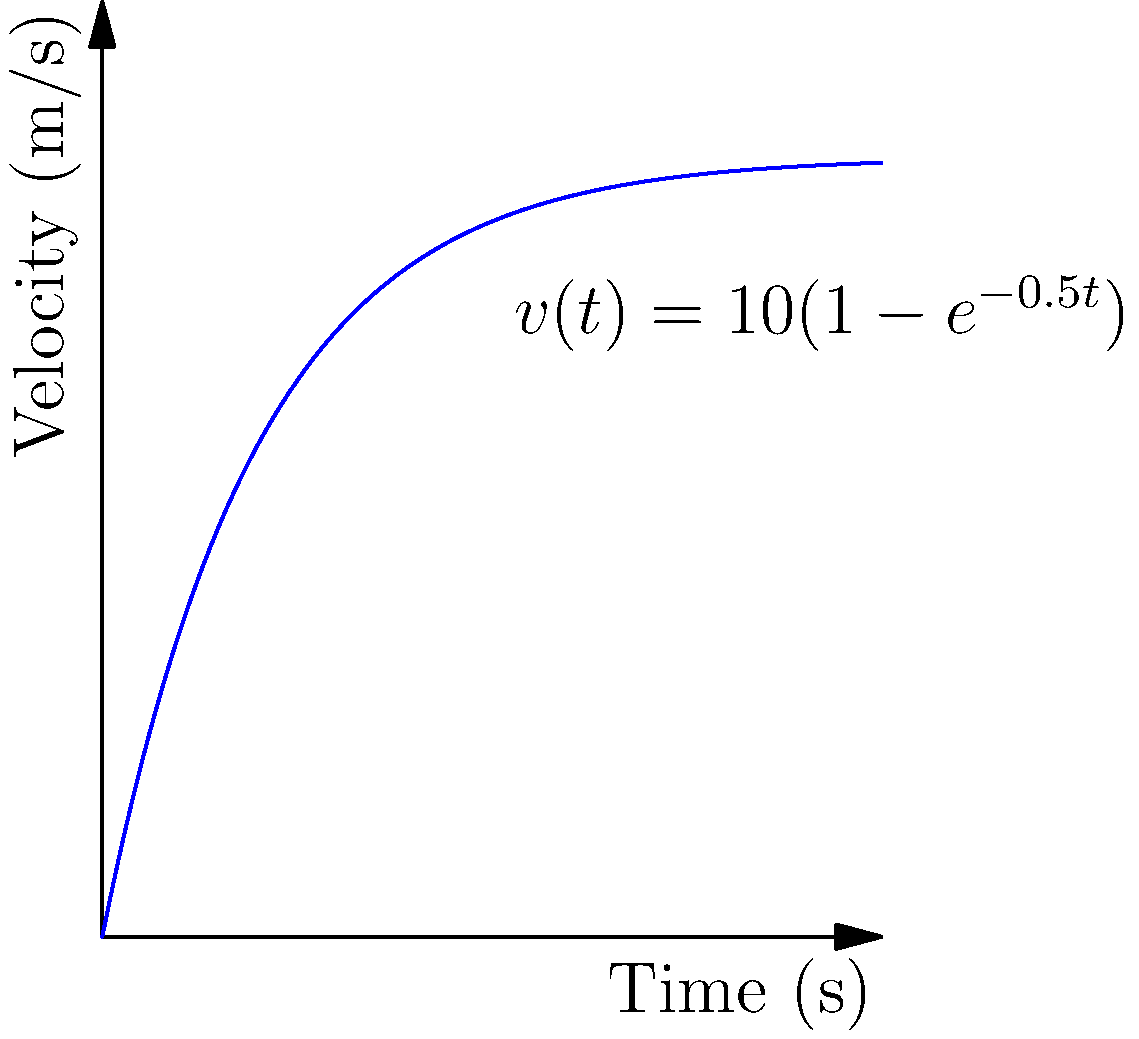A runner's velocity during a 100-meter sprint is modeled by the function $v(t) = 10(1-e^{-0.5t})$, where $v$ is in meters per second and $t$ is in seconds. Determine the runner's acceleration at $t = 2$ seconds. To find the acceleration at $t = 2$ seconds, we need to follow these steps:

1) The acceleration is the derivative of the velocity function with respect to time.

2) Let's start by finding the general expression for acceleration:
   $a(t) = \frac{dv}{dt} = \frac{d}{dt}[10(1-e^{-0.5t})]$

3) Using the chain rule:
   $a(t) = 10 \cdot \frac{d}{dt}[1-e^{-0.5t}] = 10 \cdot (-1) \cdot \frac{d}{dt}[e^{-0.5t}]$

4) The derivative of $e^x$ is $e^x$, so:
   $a(t) = 10 \cdot (-1) \cdot (-0.5) \cdot e^{-0.5t} = 5e^{-0.5t}$

5) Now, we substitute $t = 2$ into this expression:
   $a(2) = 5e^{-0.5(2)} = 5e^{-1} \approx 1.839$ m/s²

Therefore, the runner's acceleration at $t = 2$ seconds is approximately 1.839 m/s².
Answer: $5e^{-1}$ m/s² or approximately 1.839 m/s² 